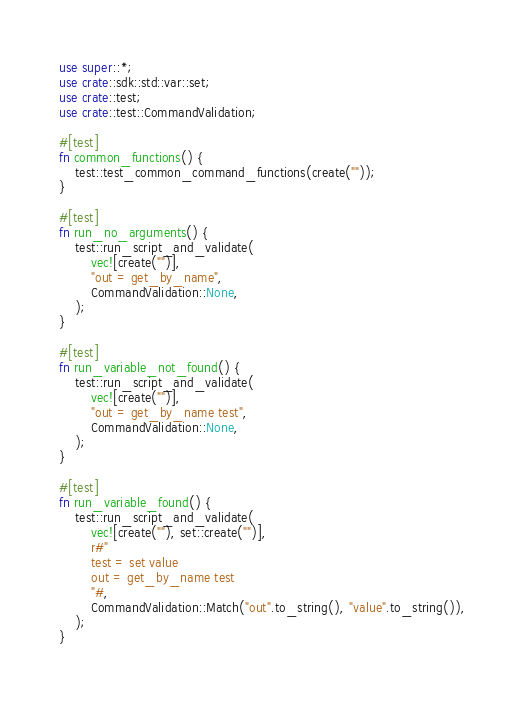Convert code to text. <code><loc_0><loc_0><loc_500><loc_500><_Rust_>use super::*;
use crate::sdk::std::var::set;
use crate::test;
use crate::test::CommandValidation;

#[test]
fn common_functions() {
    test::test_common_command_functions(create(""));
}

#[test]
fn run_no_arguments() {
    test::run_script_and_validate(
        vec![create("")],
        "out = get_by_name",
        CommandValidation::None,
    );
}

#[test]
fn run_variable_not_found() {
    test::run_script_and_validate(
        vec![create("")],
        "out = get_by_name test",
        CommandValidation::None,
    );
}

#[test]
fn run_variable_found() {
    test::run_script_and_validate(
        vec![create(""), set::create("")],
        r#"
        test = set value
        out = get_by_name test
        "#,
        CommandValidation::Match("out".to_string(), "value".to_string()),
    );
}
</code> 